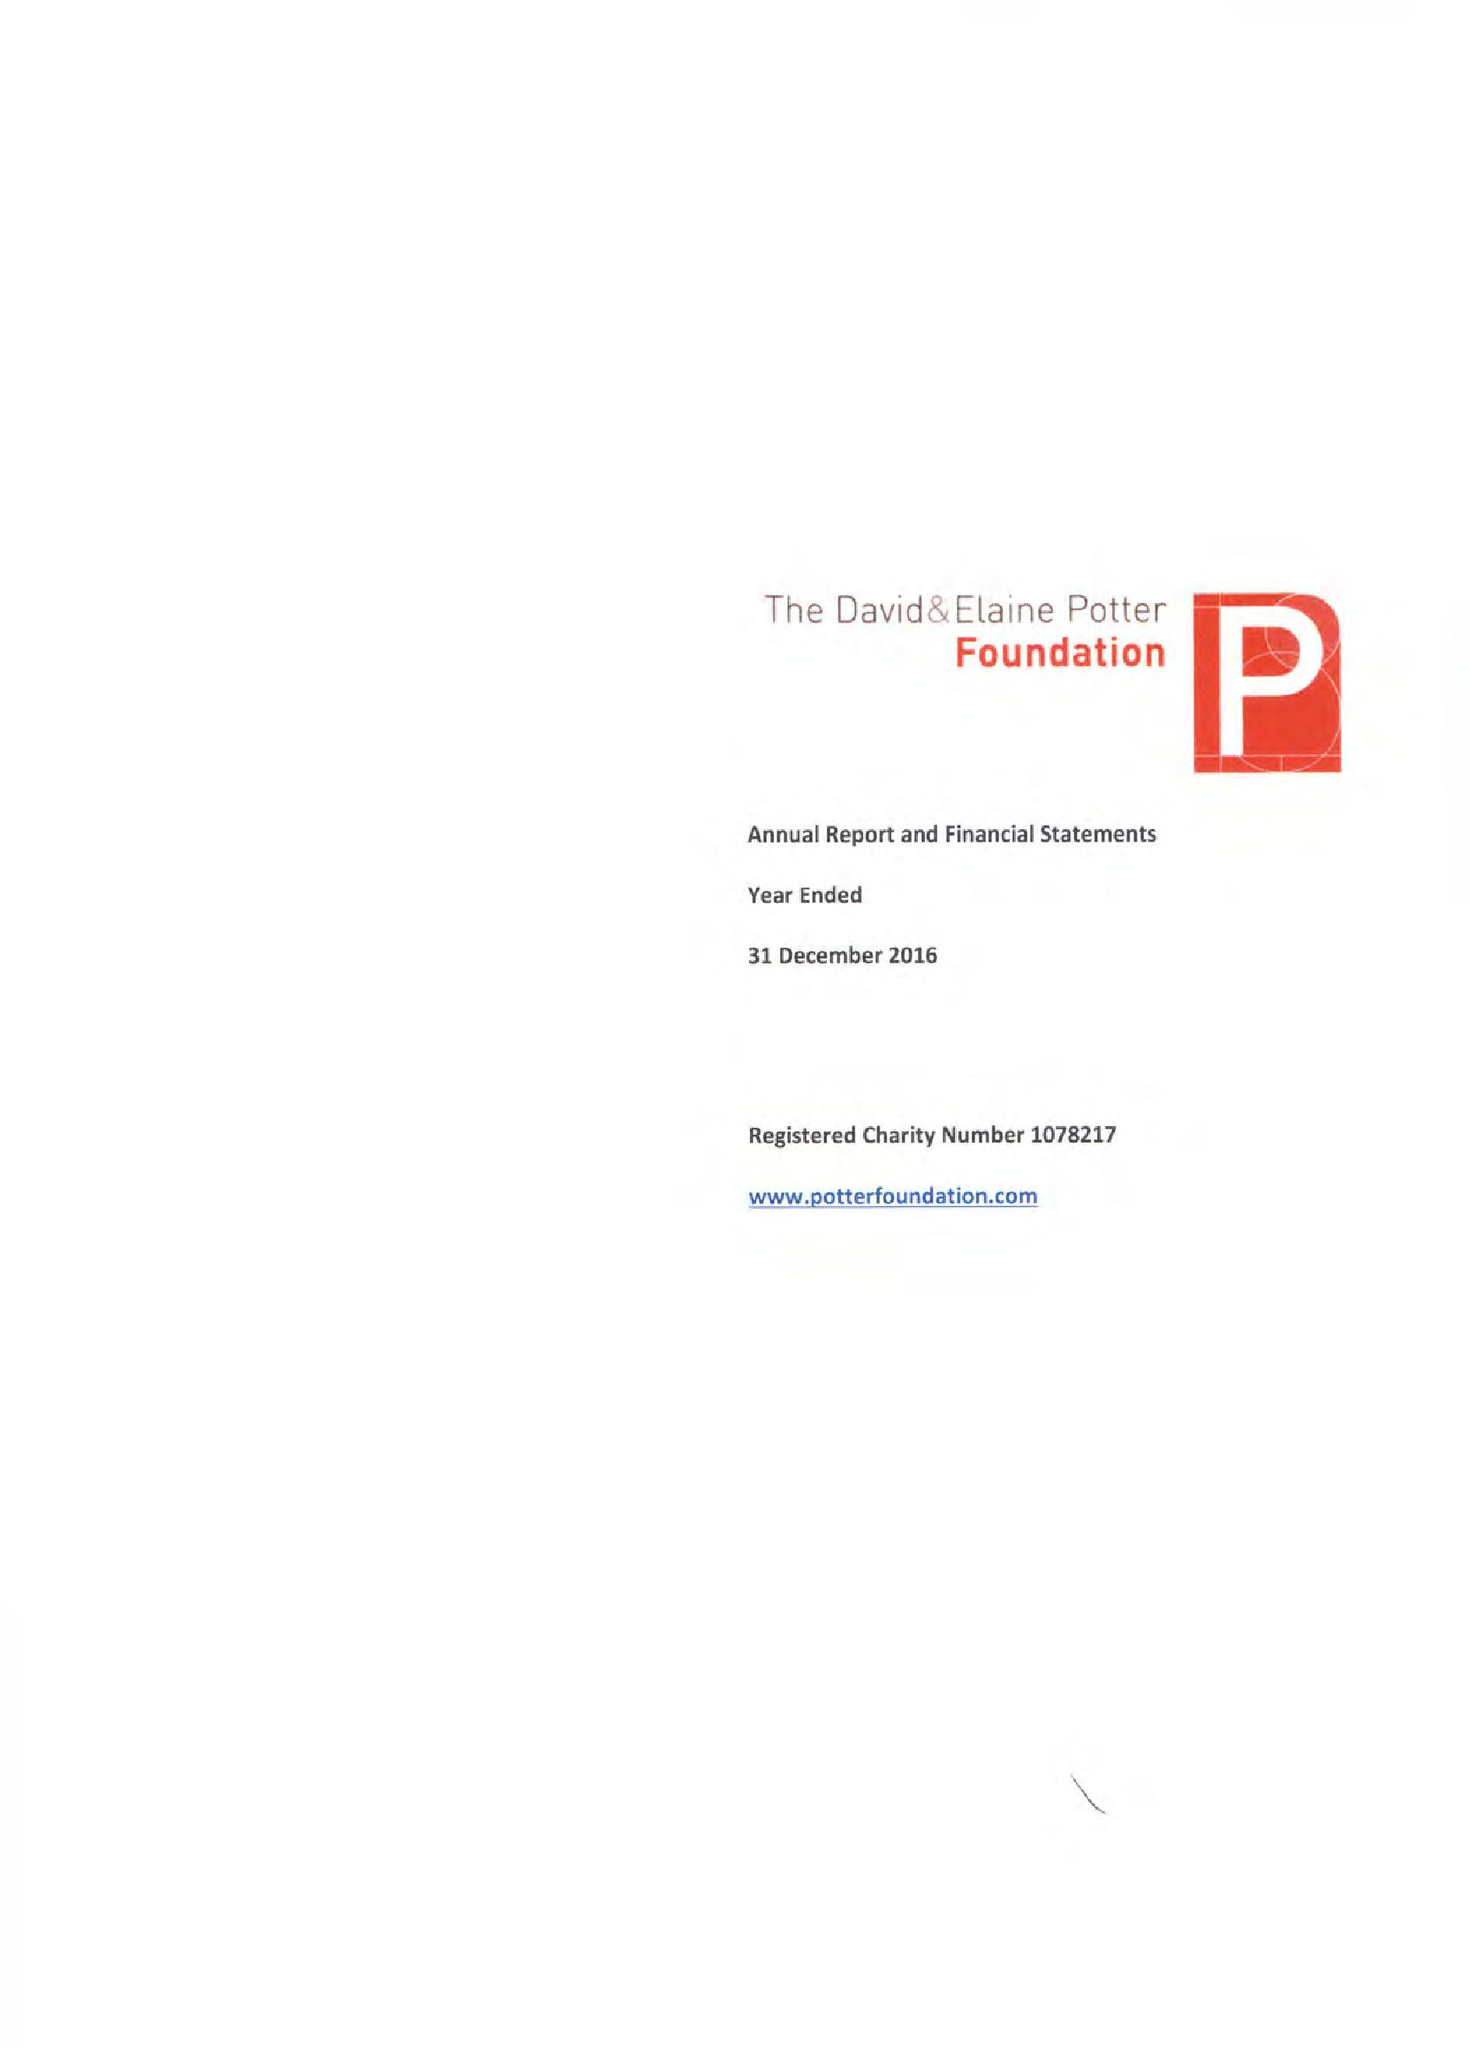What is the value for the address__street_line?
Answer the question using a single word or phrase. 5 WELBECK STREET 